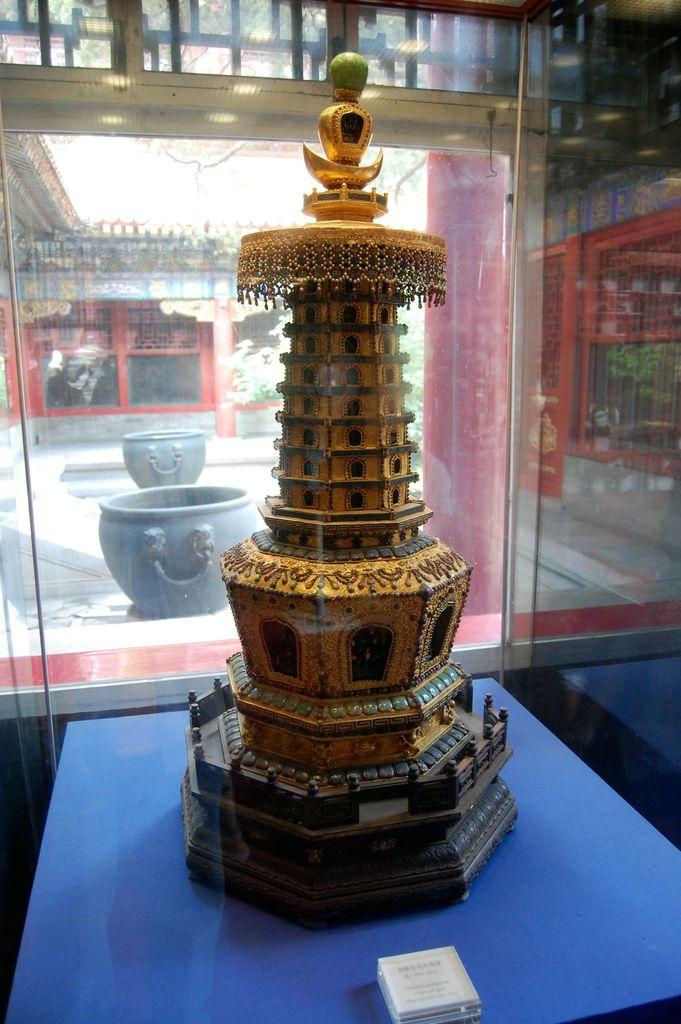What is the main subject of the image? The main subject of the image is a sculpture of a building. How is the sculpture displayed in the image? The sculpture is placed in a glass box. How many friends are sitting on the donkey in the image? There are no friends or donkeys present in the image; it features a sculpture of a building placed in a glass box. 